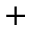Convert formula to latex. <formula><loc_0><loc_0><loc_500><loc_500>^ { + }</formula> 